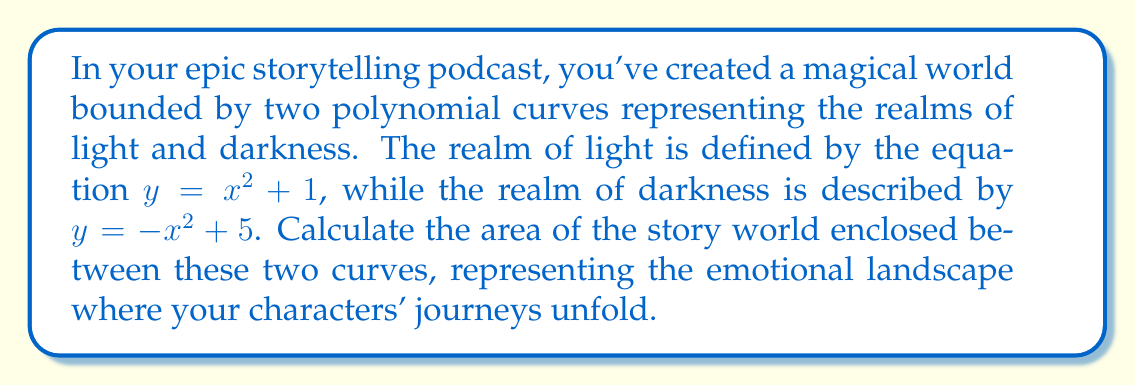Teach me how to tackle this problem. To find the area enclosed between these two curves, we'll follow these steps:

1. Find the points of intersection:
   Set the equations equal to each other:
   $$x^2 + 1 = -x^2 + 5$$
   $$2x^2 = 4$$
   $$x^2 = 2$$
   $$x = \pm\sqrt{2}$$

2. The area is symmetrical about the y-axis, so we'll calculate the area of one half and double it.

3. Set up the integral:
   $$\text{Area} = 2 \int_0^{\sqrt{2}} [(-x^2 + 5) - (x^2 + 1)] dx$$

4. Simplify the integrand:
   $$\text{Area} = 2 \int_0^{\sqrt{2}} [-2x^2 + 4] dx$$

5. Integrate:
   $$\text{Area} = 2 \left[-\frac{2x^3}{3} + 4x\right]_0^{\sqrt{2}}$$

6. Evaluate the integral:
   $$\text{Area} = 2 \left[\left(-\frac{2(\sqrt{2})^3}{3} + 4\sqrt{2}\right) - \left(-\frac{2(0)^3}{3} + 4(0)\right)\right]$$
   $$\text{Area} = 2 \left[-\frac{2(2\sqrt{2})}{3} + 4\sqrt{2}\right]$$
   $$\text{Area} = 2 \left[-\frac{4\sqrt{2}}{3} + 4\sqrt{2}\right]$$
   $$\text{Area} = 2 \left[\frac{8\sqrt{2}}{3}\right]$$
   $$\text{Area} = \frac{16\sqrt{2}}{3}$$

[asy]
import graph;
size(200);
real f(real x) {return x^2 + 1;}
real g(real x) {return -x^2 + 5;}
draw(graph(f, -sqrt(2), sqrt(2)), blue);
draw(graph(g, -sqrt(2), sqrt(2)), red);
fill(graph(g, -sqrt(2), sqrt(2)) -- graph(f, sqrt(2), -sqrt(2)) -- cycle, palegreen);
label("Light realm", (1.5, 3.5), blue);
label("Dark realm", (-1.5, 3.5), red);
label("Story world", (0, 2.5), green);
xaxis("x", -2, 2, Arrow);
yaxis("y", 0, 6, Arrow);
[/asy]
Answer: $\frac{16\sqrt{2}}{3}$ square units 